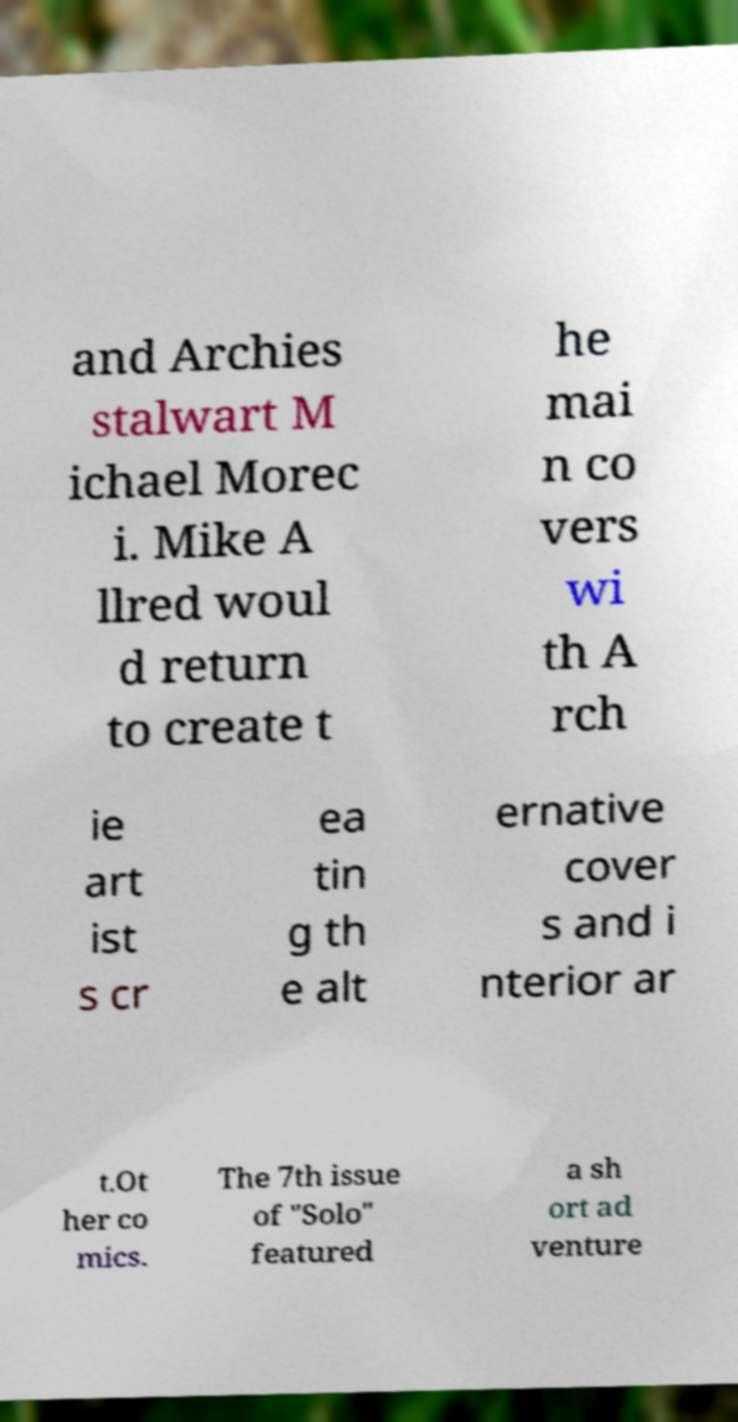Could you extract and type out the text from this image? and Archies stalwart M ichael Morec i. Mike A llred woul d return to create t he mai n co vers wi th A rch ie art ist s cr ea tin g th e alt ernative cover s and i nterior ar t.Ot her co mics. The 7th issue of "Solo" featured a sh ort ad venture 